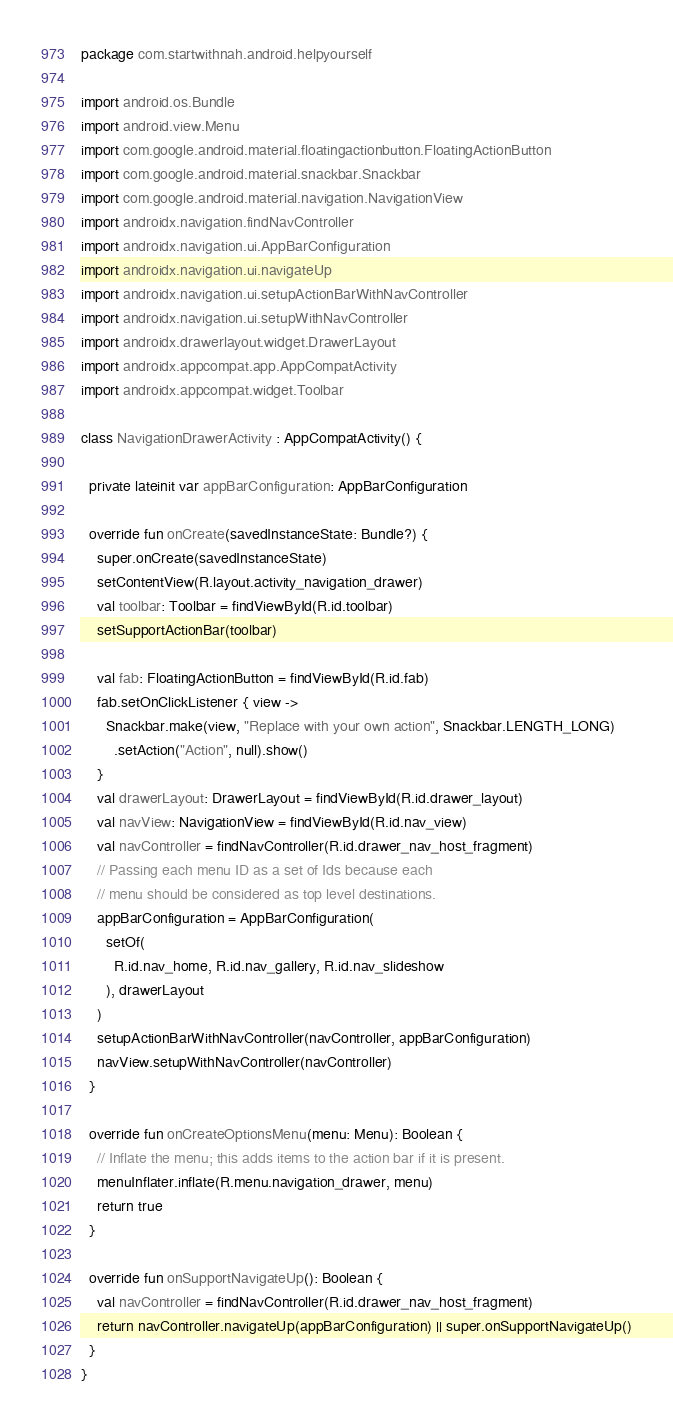<code> <loc_0><loc_0><loc_500><loc_500><_Kotlin_>package com.startwithnah.android.helpyourself

import android.os.Bundle
import android.view.Menu
import com.google.android.material.floatingactionbutton.FloatingActionButton
import com.google.android.material.snackbar.Snackbar
import com.google.android.material.navigation.NavigationView
import androidx.navigation.findNavController
import androidx.navigation.ui.AppBarConfiguration
import androidx.navigation.ui.navigateUp
import androidx.navigation.ui.setupActionBarWithNavController
import androidx.navigation.ui.setupWithNavController
import androidx.drawerlayout.widget.DrawerLayout
import androidx.appcompat.app.AppCompatActivity
import androidx.appcompat.widget.Toolbar

class NavigationDrawerActivity : AppCompatActivity() {

  private lateinit var appBarConfiguration: AppBarConfiguration

  override fun onCreate(savedInstanceState: Bundle?) {
    super.onCreate(savedInstanceState)
    setContentView(R.layout.activity_navigation_drawer)
    val toolbar: Toolbar = findViewById(R.id.toolbar)
    setSupportActionBar(toolbar)

    val fab: FloatingActionButton = findViewById(R.id.fab)
    fab.setOnClickListener { view ->
      Snackbar.make(view, "Replace with your own action", Snackbar.LENGTH_LONG)
        .setAction("Action", null).show()
    }
    val drawerLayout: DrawerLayout = findViewById(R.id.drawer_layout)
    val navView: NavigationView = findViewById(R.id.nav_view)
    val navController = findNavController(R.id.drawer_nav_host_fragment)
    // Passing each menu ID as a set of Ids because each
    // menu should be considered as top level destinations.
    appBarConfiguration = AppBarConfiguration(
      setOf(
        R.id.nav_home, R.id.nav_gallery, R.id.nav_slideshow
      ), drawerLayout
    )
    setupActionBarWithNavController(navController, appBarConfiguration)
    navView.setupWithNavController(navController)
  }

  override fun onCreateOptionsMenu(menu: Menu): Boolean {
    // Inflate the menu; this adds items to the action bar if it is present.
    menuInflater.inflate(R.menu.navigation_drawer, menu)
    return true
  }

  override fun onSupportNavigateUp(): Boolean {
    val navController = findNavController(R.id.drawer_nav_host_fragment)
    return navController.navigateUp(appBarConfiguration) || super.onSupportNavigateUp()
  }
}</code> 